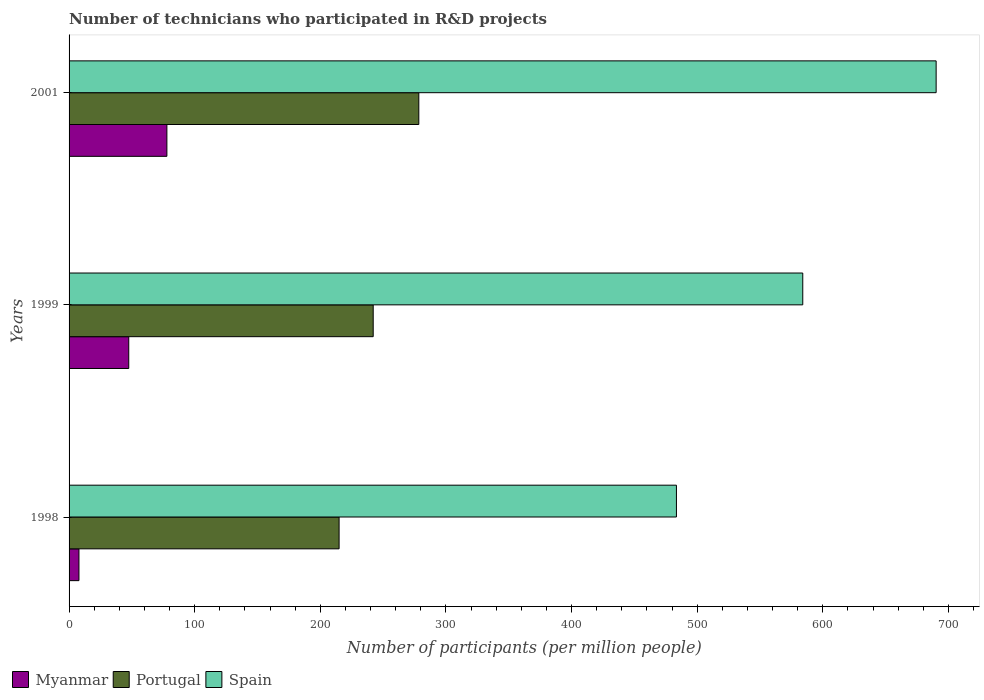How many different coloured bars are there?
Ensure brevity in your answer.  3. Are the number of bars on each tick of the Y-axis equal?
Your answer should be compact. Yes. What is the label of the 1st group of bars from the top?
Keep it short and to the point. 2001. What is the number of technicians who participated in R&D projects in Myanmar in 1998?
Provide a short and direct response. 7.87. Across all years, what is the maximum number of technicians who participated in R&D projects in Portugal?
Ensure brevity in your answer.  278.43. Across all years, what is the minimum number of technicians who participated in R&D projects in Portugal?
Your answer should be compact. 214.96. In which year was the number of technicians who participated in R&D projects in Myanmar maximum?
Make the answer very short. 2001. What is the total number of technicians who participated in R&D projects in Spain in the graph?
Make the answer very short. 1757.87. What is the difference between the number of technicians who participated in R&D projects in Myanmar in 1999 and that in 2001?
Offer a terse response. -30.36. What is the difference between the number of technicians who participated in R&D projects in Portugal in 1998 and the number of technicians who participated in R&D projects in Myanmar in 1999?
Ensure brevity in your answer.  167.45. What is the average number of technicians who participated in R&D projects in Portugal per year?
Keep it short and to the point. 245.17. In the year 2001, what is the difference between the number of technicians who participated in R&D projects in Myanmar and number of technicians who participated in R&D projects in Portugal?
Offer a terse response. -200.56. What is the ratio of the number of technicians who participated in R&D projects in Myanmar in 1998 to that in 2001?
Your answer should be compact. 0.1. Is the difference between the number of technicians who participated in R&D projects in Myanmar in 1998 and 1999 greater than the difference between the number of technicians who participated in R&D projects in Portugal in 1998 and 1999?
Keep it short and to the point. No. What is the difference between the highest and the second highest number of technicians who participated in R&D projects in Myanmar?
Offer a terse response. 30.36. What is the difference between the highest and the lowest number of technicians who participated in R&D projects in Myanmar?
Offer a terse response. 70. Is the sum of the number of technicians who participated in R&D projects in Spain in 1998 and 1999 greater than the maximum number of technicians who participated in R&D projects in Portugal across all years?
Provide a succinct answer. Yes. What does the 3rd bar from the top in 1999 represents?
Keep it short and to the point. Myanmar. What does the 3rd bar from the bottom in 1999 represents?
Offer a very short reply. Spain. Is it the case that in every year, the sum of the number of technicians who participated in R&D projects in Myanmar and number of technicians who participated in R&D projects in Portugal is greater than the number of technicians who participated in R&D projects in Spain?
Give a very brief answer. No. How many years are there in the graph?
Give a very brief answer. 3. Are the values on the major ticks of X-axis written in scientific E-notation?
Provide a short and direct response. No. Does the graph contain any zero values?
Offer a terse response. No. Where does the legend appear in the graph?
Your response must be concise. Bottom left. How are the legend labels stacked?
Offer a terse response. Horizontal. What is the title of the graph?
Your response must be concise. Number of technicians who participated in R&D projects. Does "Somalia" appear as one of the legend labels in the graph?
Keep it short and to the point. No. What is the label or title of the X-axis?
Provide a short and direct response. Number of participants (per million people). What is the Number of participants (per million people) in Myanmar in 1998?
Provide a succinct answer. 7.87. What is the Number of participants (per million people) in Portugal in 1998?
Make the answer very short. 214.96. What is the Number of participants (per million people) of Spain in 1998?
Provide a succinct answer. 483.52. What is the Number of participants (per million people) of Myanmar in 1999?
Your response must be concise. 47.51. What is the Number of participants (per million people) of Portugal in 1999?
Give a very brief answer. 242.12. What is the Number of participants (per million people) in Spain in 1999?
Offer a very short reply. 584.09. What is the Number of participants (per million people) of Myanmar in 2001?
Make the answer very short. 77.87. What is the Number of participants (per million people) in Portugal in 2001?
Provide a succinct answer. 278.43. What is the Number of participants (per million people) in Spain in 2001?
Provide a short and direct response. 690.27. Across all years, what is the maximum Number of participants (per million people) of Myanmar?
Give a very brief answer. 77.87. Across all years, what is the maximum Number of participants (per million people) in Portugal?
Offer a very short reply. 278.43. Across all years, what is the maximum Number of participants (per million people) of Spain?
Your answer should be very brief. 690.27. Across all years, what is the minimum Number of participants (per million people) in Myanmar?
Your answer should be very brief. 7.87. Across all years, what is the minimum Number of participants (per million people) of Portugal?
Offer a very short reply. 214.96. Across all years, what is the minimum Number of participants (per million people) of Spain?
Provide a short and direct response. 483.52. What is the total Number of participants (per million people) in Myanmar in the graph?
Your answer should be compact. 133.25. What is the total Number of participants (per million people) of Portugal in the graph?
Offer a terse response. 735.51. What is the total Number of participants (per million people) in Spain in the graph?
Give a very brief answer. 1757.87. What is the difference between the Number of participants (per million people) of Myanmar in 1998 and that in 1999?
Your answer should be very brief. -39.64. What is the difference between the Number of participants (per million people) of Portugal in 1998 and that in 1999?
Keep it short and to the point. -27.16. What is the difference between the Number of participants (per million people) in Spain in 1998 and that in 1999?
Keep it short and to the point. -100.58. What is the difference between the Number of participants (per million people) in Myanmar in 1998 and that in 2001?
Your answer should be very brief. -70. What is the difference between the Number of participants (per million people) in Portugal in 1998 and that in 2001?
Your answer should be compact. -63.47. What is the difference between the Number of participants (per million people) in Spain in 1998 and that in 2001?
Offer a very short reply. -206.75. What is the difference between the Number of participants (per million people) in Myanmar in 1999 and that in 2001?
Your response must be concise. -30.36. What is the difference between the Number of participants (per million people) of Portugal in 1999 and that in 2001?
Your response must be concise. -36.31. What is the difference between the Number of participants (per million people) in Spain in 1999 and that in 2001?
Provide a short and direct response. -106.17. What is the difference between the Number of participants (per million people) of Myanmar in 1998 and the Number of participants (per million people) of Portugal in 1999?
Give a very brief answer. -234.25. What is the difference between the Number of participants (per million people) in Myanmar in 1998 and the Number of participants (per million people) in Spain in 1999?
Give a very brief answer. -576.22. What is the difference between the Number of participants (per million people) of Portugal in 1998 and the Number of participants (per million people) of Spain in 1999?
Your answer should be compact. -369.13. What is the difference between the Number of participants (per million people) in Myanmar in 1998 and the Number of participants (per million people) in Portugal in 2001?
Provide a short and direct response. -270.56. What is the difference between the Number of participants (per million people) of Myanmar in 1998 and the Number of participants (per million people) of Spain in 2001?
Keep it short and to the point. -682.4. What is the difference between the Number of participants (per million people) in Portugal in 1998 and the Number of participants (per million people) in Spain in 2001?
Ensure brevity in your answer.  -475.31. What is the difference between the Number of participants (per million people) in Myanmar in 1999 and the Number of participants (per million people) in Portugal in 2001?
Offer a terse response. -230.92. What is the difference between the Number of participants (per million people) of Myanmar in 1999 and the Number of participants (per million people) of Spain in 2001?
Give a very brief answer. -642.76. What is the difference between the Number of participants (per million people) in Portugal in 1999 and the Number of participants (per million people) in Spain in 2001?
Your answer should be compact. -448.15. What is the average Number of participants (per million people) of Myanmar per year?
Offer a very short reply. 44.42. What is the average Number of participants (per million people) of Portugal per year?
Your answer should be compact. 245.17. What is the average Number of participants (per million people) of Spain per year?
Make the answer very short. 585.96. In the year 1998, what is the difference between the Number of participants (per million people) of Myanmar and Number of participants (per million people) of Portugal?
Offer a very short reply. -207.09. In the year 1998, what is the difference between the Number of participants (per million people) of Myanmar and Number of participants (per million people) of Spain?
Keep it short and to the point. -475.65. In the year 1998, what is the difference between the Number of participants (per million people) of Portugal and Number of participants (per million people) of Spain?
Ensure brevity in your answer.  -268.56. In the year 1999, what is the difference between the Number of participants (per million people) of Myanmar and Number of participants (per million people) of Portugal?
Your answer should be compact. -194.61. In the year 1999, what is the difference between the Number of participants (per million people) of Myanmar and Number of participants (per million people) of Spain?
Provide a succinct answer. -536.58. In the year 1999, what is the difference between the Number of participants (per million people) in Portugal and Number of participants (per million people) in Spain?
Offer a very short reply. -341.98. In the year 2001, what is the difference between the Number of participants (per million people) in Myanmar and Number of participants (per million people) in Portugal?
Your answer should be compact. -200.56. In the year 2001, what is the difference between the Number of participants (per million people) of Myanmar and Number of participants (per million people) of Spain?
Your answer should be very brief. -612.4. In the year 2001, what is the difference between the Number of participants (per million people) in Portugal and Number of participants (per million people) in Spain?
Make the answer very short. -411.84. What is the ratio of the Number of participants (per million people) in Myanmar in 1998 to that in 1999?
Make the answer very short. 0.17. What is the ratio of the Number of participants (per million people) of Portugal in 1998 to that in 1999?
Your answer should be compact. 0.89. What is the ratio of the Number of participants (per million people) of Spain in 1998 to that in 1999?
Provide a succinct answer. 0.83. What is the ratio of the Number of participants (per million people) in Myanmar in 1998 to that in 2001?
Offer a very short reply. 0.1. What is the ratio of the Number of participants (per million people) in Portugal in 1998 to that in 2001?
Offer a very short reply. 0.77. What is the ratio of the Number of participants (per million people) in Spain in 1998 to that in 2001?
Offer a terse response. 0.7. What is the ratio of the Number of participants (per million people) of Myanmar in 1999 to that in 2001?
Provide a succinct answer. 0.61. What is the ratio of the Number of participants (per million people) in Portugal in 1999 to that in 2001?
Provide a succinct answer. 0.87. What is the ratio of the Number of participants (per million people) in Spain in 1999 to that in 2001?
Give a very brief answer. 0.85. What is the difference between the highest and the second highest Number of participants (per million people) in Myanmar?
Offer a very short reply. 30.36. What is the difference between the highest and the second highest Number of participants (per million people) in Portugal?
Offer a terse response. 36.31. What is the difference between the highest and the second highest Number of participants (per million people) in Spain?
Keep it short and to the point. 106.17. What is the difference between the highest and the lowest Number of participants (per million people) in Myanmar?
Offer a very short reply. 70. What is the difference between the highest and the lowest Number of participants (per million people) of Portugal?
Your response must be concise. 63.47. What is the difference between the highest and the lowest Number of participants (per million people) in Spain?
Keep it short and to the point. 206.75. 